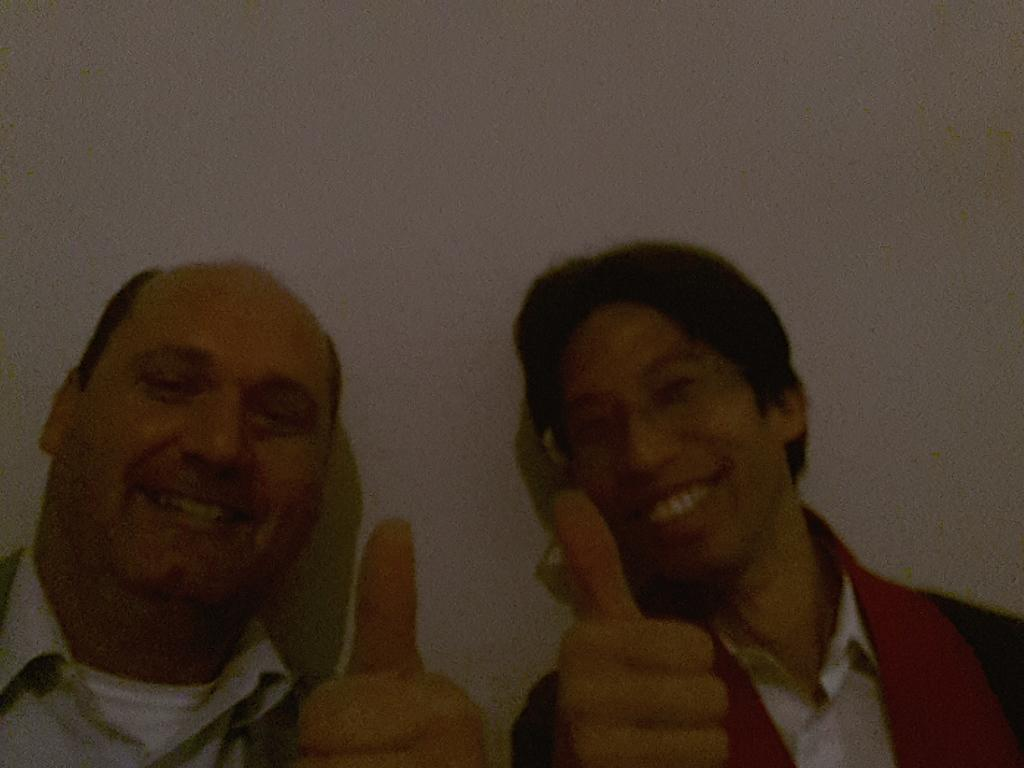Who is present in the foreground of the picture? There are men in the foreground of the picture. What are the men doing in the picture? The men are showing thumbs up to the camera. What can be seen in the background of the picture? There is a wall in the background of the picture. What type of feast is being prepared in the background of the image? There is no feast or any indication of food preparation in the image; it only features men showing thumbs up and a wall in the background. 